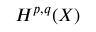<formula> <loc_0><loc_0><loc_500><loc_500>H ^ { p , q } ( X )</formula> 